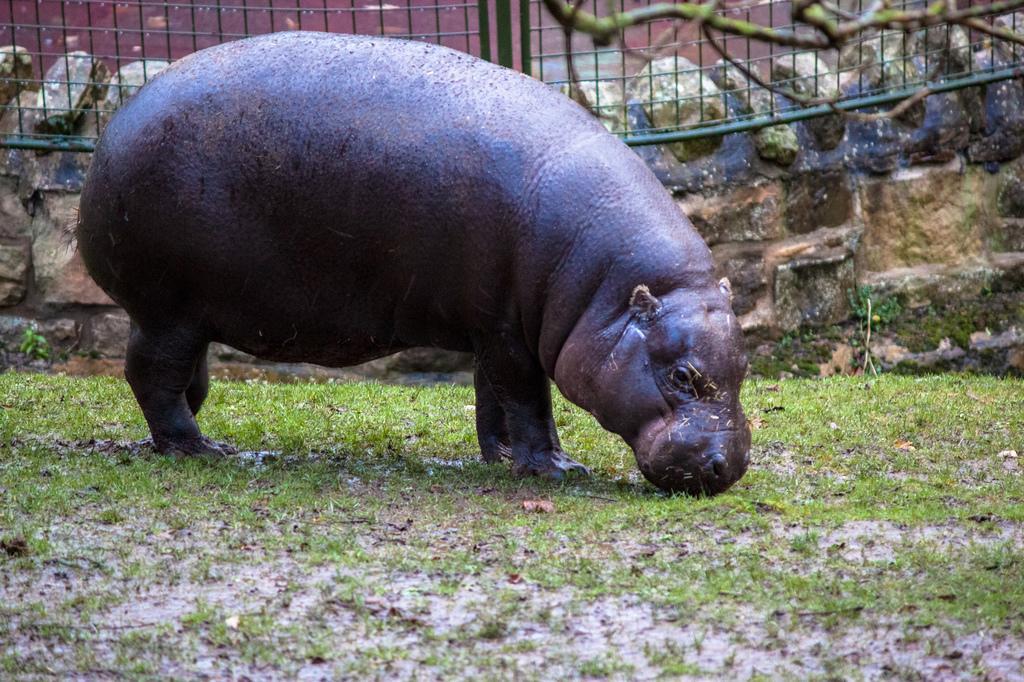Could you give a brief overview of what you see in this image? In this picture, we can see an animal on the ground, and we can see the ground with grass, and we can see the wall, fencing, and some object on top right side of the picture. 